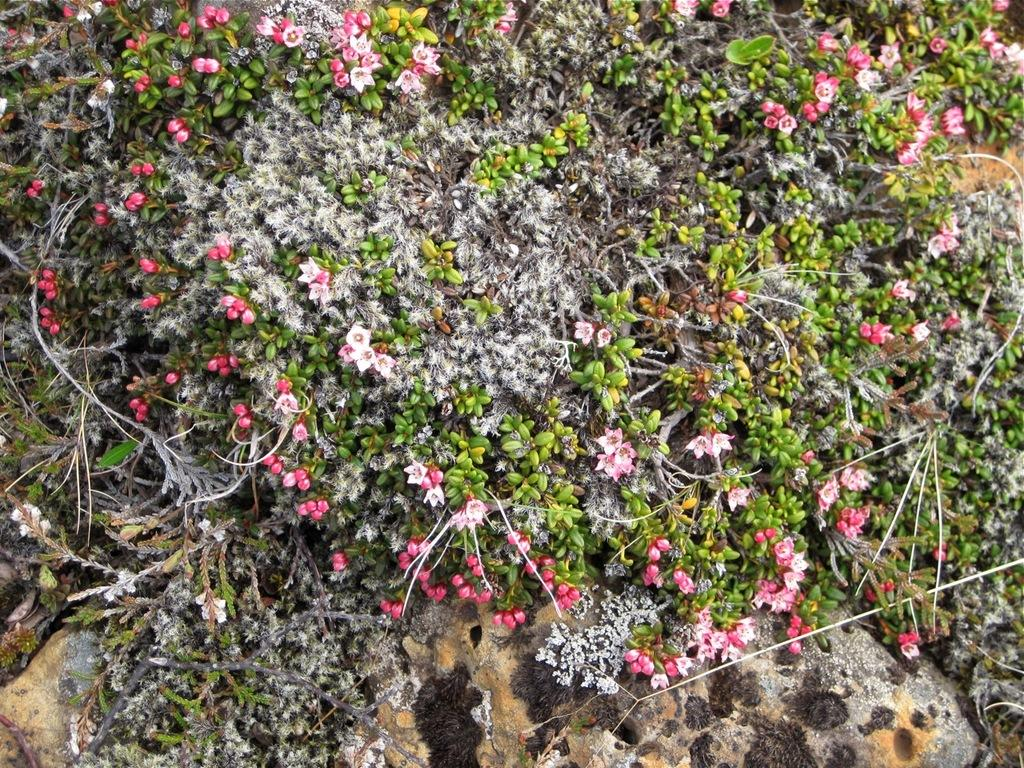What type of living organisms are in the image? The image contains plants. What specific features can be observed on the plants? The plants have flowers and stems. What type of needle can be seen in the image? There is no needle present in the image; it features plants with flowers and stems. How many sisters are visible in the image? There is no reference to any sisters in the image; it only contains plants with flowers and stems. 